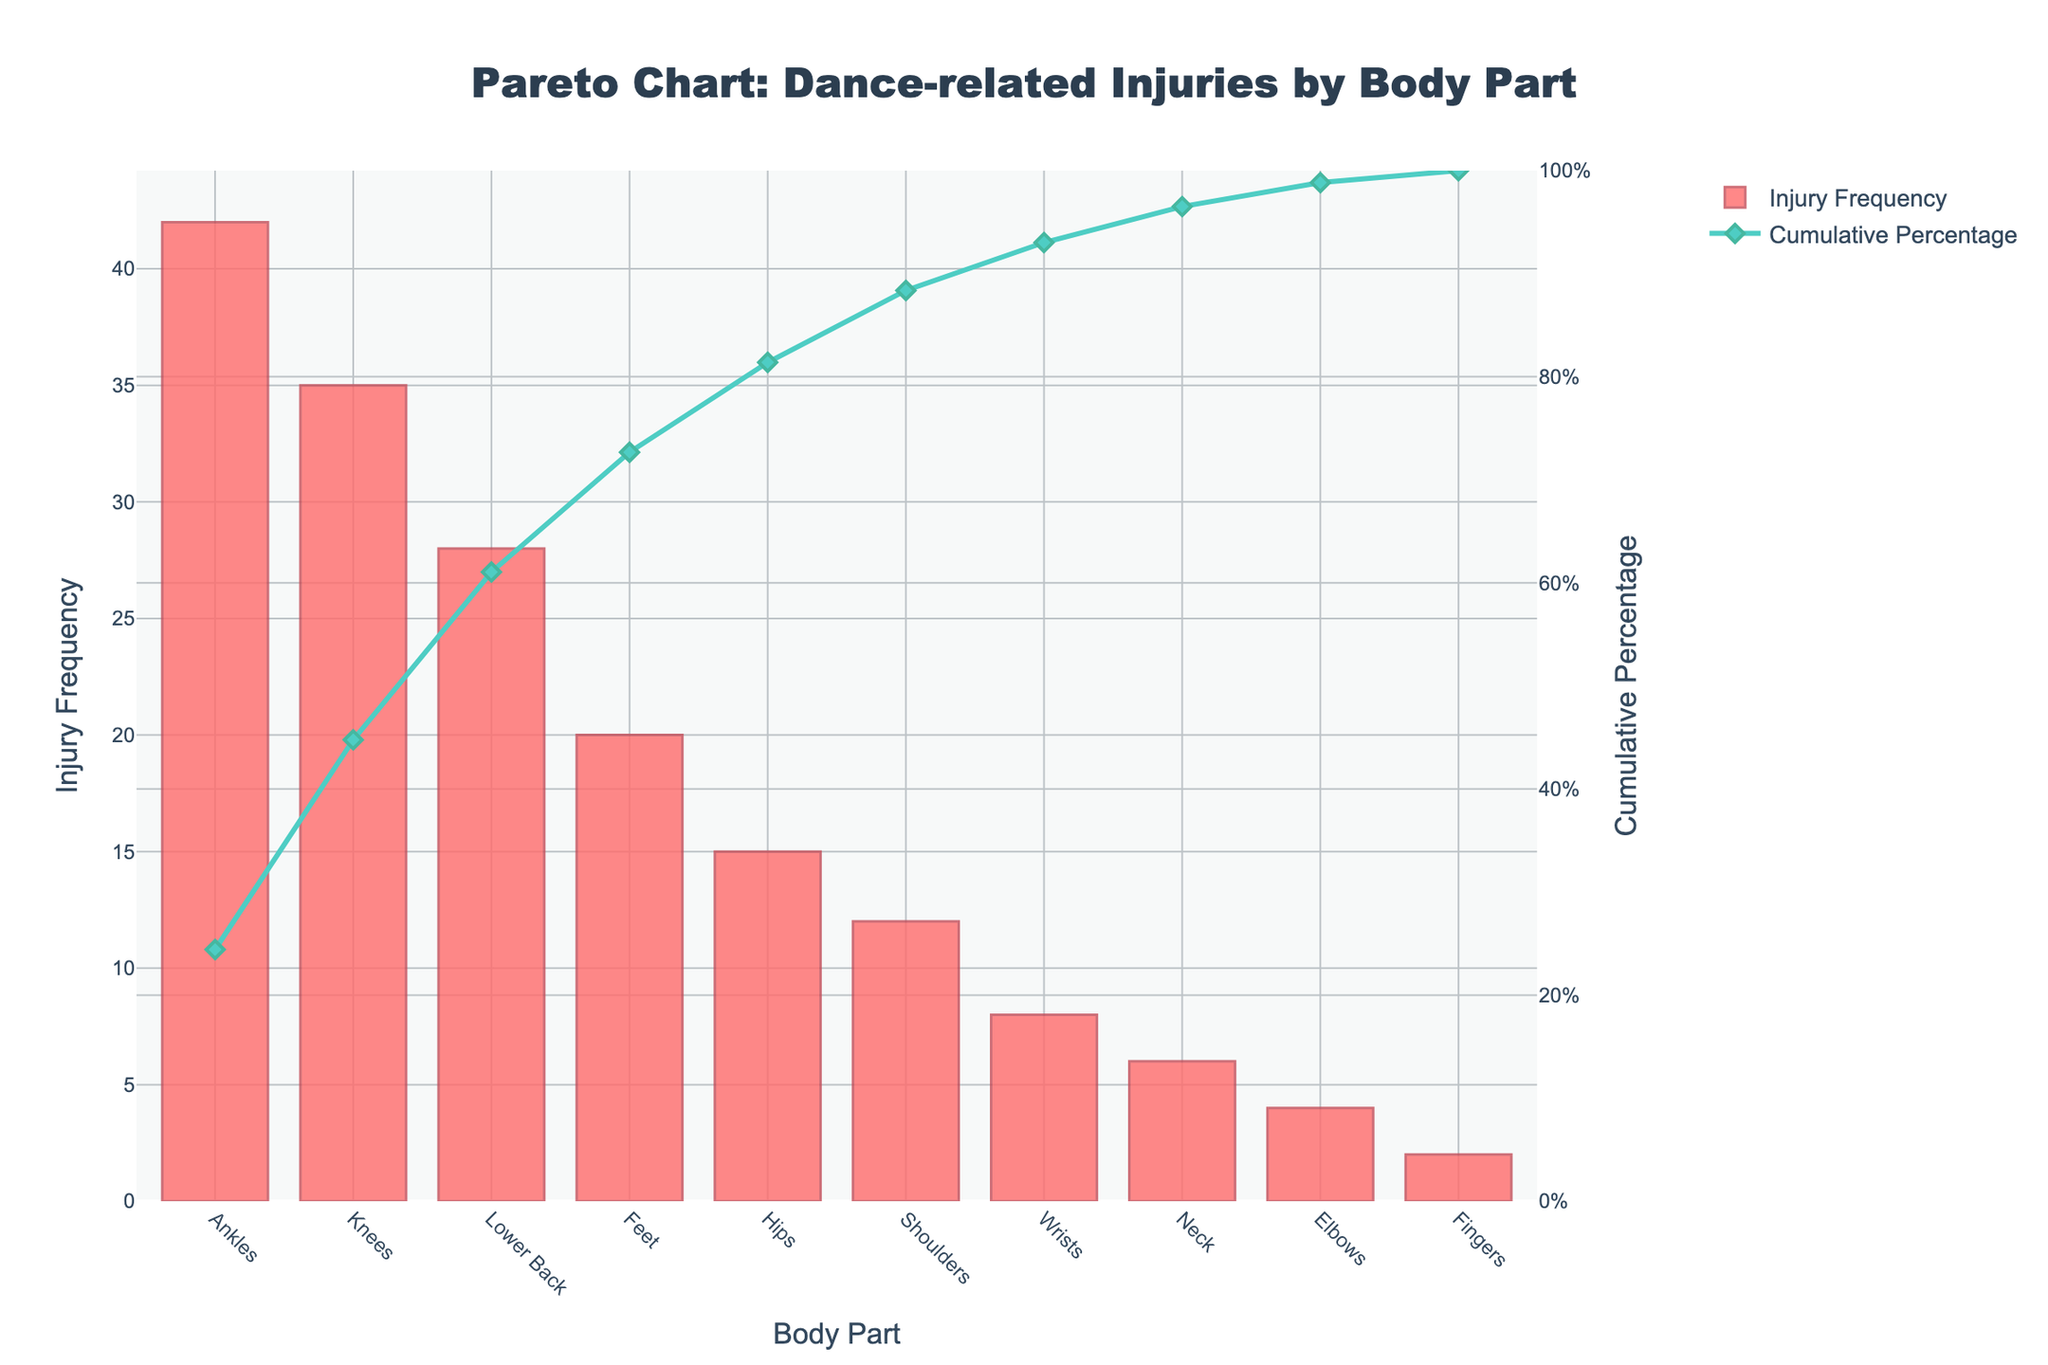what is the title of the chart? The title of the chart is clearly indicated at the top center of the figure.
Answer: Pareto Chart: Dance-related Injuries by Body Part How many body parts are listed in the chart? Count the number of bars on the chart which represent different body parts.
Answer: 10 Which body part has the highest injury frequency? Look for the tallest bar on the chart as it represents the highest frequency.
Answer: Ankles What is the cumulative percentage for the ankles? Find the point on the cumulative percentage line that aligns with the 'Ankles' bar on the x-axis.
Answer: 20.19% Which two body parts together account for more than 50% of injuries? Identify the cumulative percentages of the body parts by adding them until the sum exceeds 50%.
Answer: Ankles and Knees What is the injury frequency for the lower back? Locate the bar corresponding to 'Lower Back' and read its height on the y-axis.
Answer: 28 What is the difference in injury frequency between the feet and the hips? Subtract the injury frequency of 'Hips' from 'Feet'.
Answer: 5 How many body parts have an injury frequency of more than 15? Count the number of bars with heights greater than 15 on the y-axis.
Answer: 4 Which body part has a cumulative percentage closest to 75%? Find the point on the cumulative percentage line that is nearest to 75% and see which body part it aligns with.
Answer: Feet What is the color of the cumulative percentage line? Observe the color designated for the line chart representing cumulative percentage.
Answer: Teal 